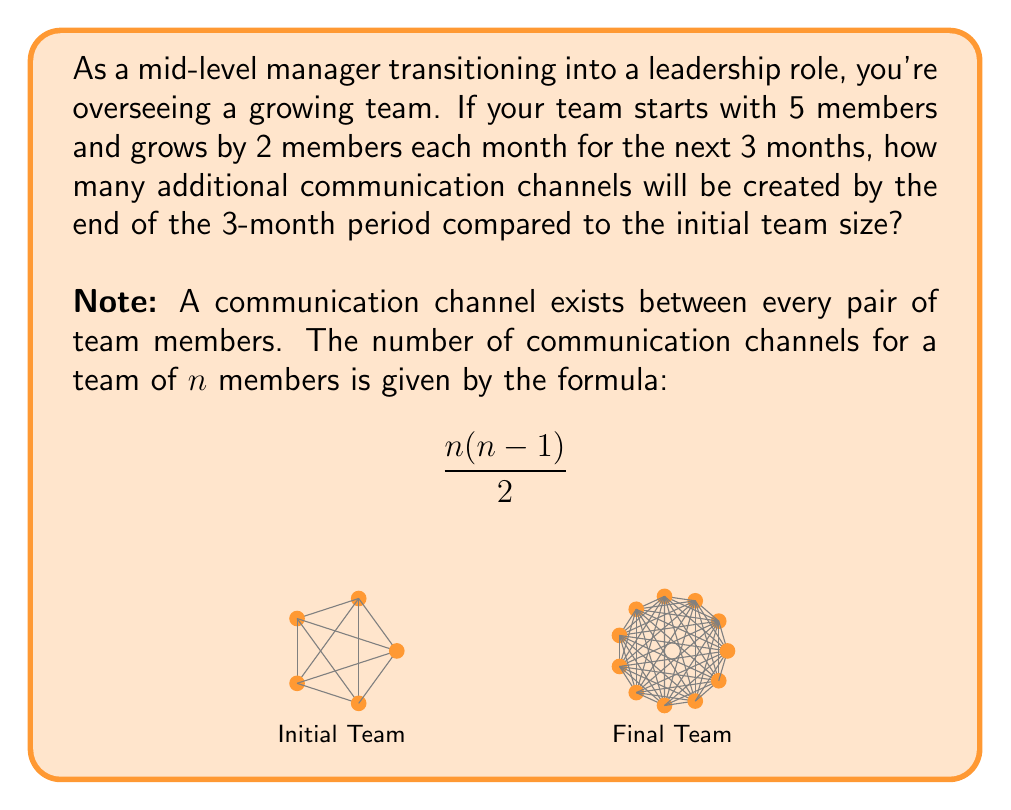Could you help me with this problem? Let's approach this step-by-step:

1) Initial team size: 5 members
   After 3 months: 5 + (2 × 3) = 11 members

2) Calculate the number of communication channels for the initial team:
   $$\frac{5(5-1)}{2} = \frac{5 \times 4}{2} = 10$$ channels

3) Calculate the number of communication channels for the final team:
   $$\frac{11(11-1)}{2} = \frac{11 \times 10}{2} = 55$$ channels

4) To find the additional channels created, subtract the initial from the final:
   55 - 10 = 45 additional channels

Therefore, 45 additional communication channels will be created by the end of the 3-month period compared to the initial team size.
Answer: 45 additional channels 